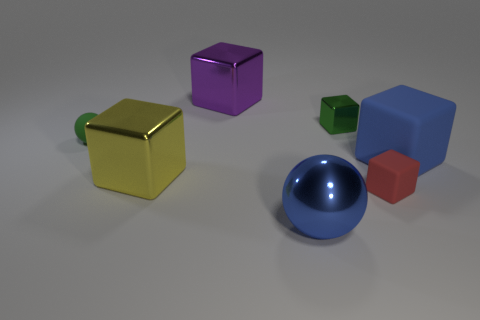Subtract all yellow shiny cubes. How many cubes are left? 4 Subtract 2 balls. How many balls are left? 0 Subtract all red cubes. How many cubes are left? 4 Subtract all cubes. How many objects are left? 2 Subtract all large cyan shiny blocks. Subtract all big blue rubber blocks. How many objects are left? 6 Add 3 blue balls. How many blue balls are left? 4 Add 6 tiny green shiny objects. How many tiny green shiny objects exist? 7 Add 1 spheres. How many objects exist? 8 Subtract 0 green cylinders. How many objects are left? 7 Subtract all green blocks. Subtract all yellow balls. How many blocks are left? 4 